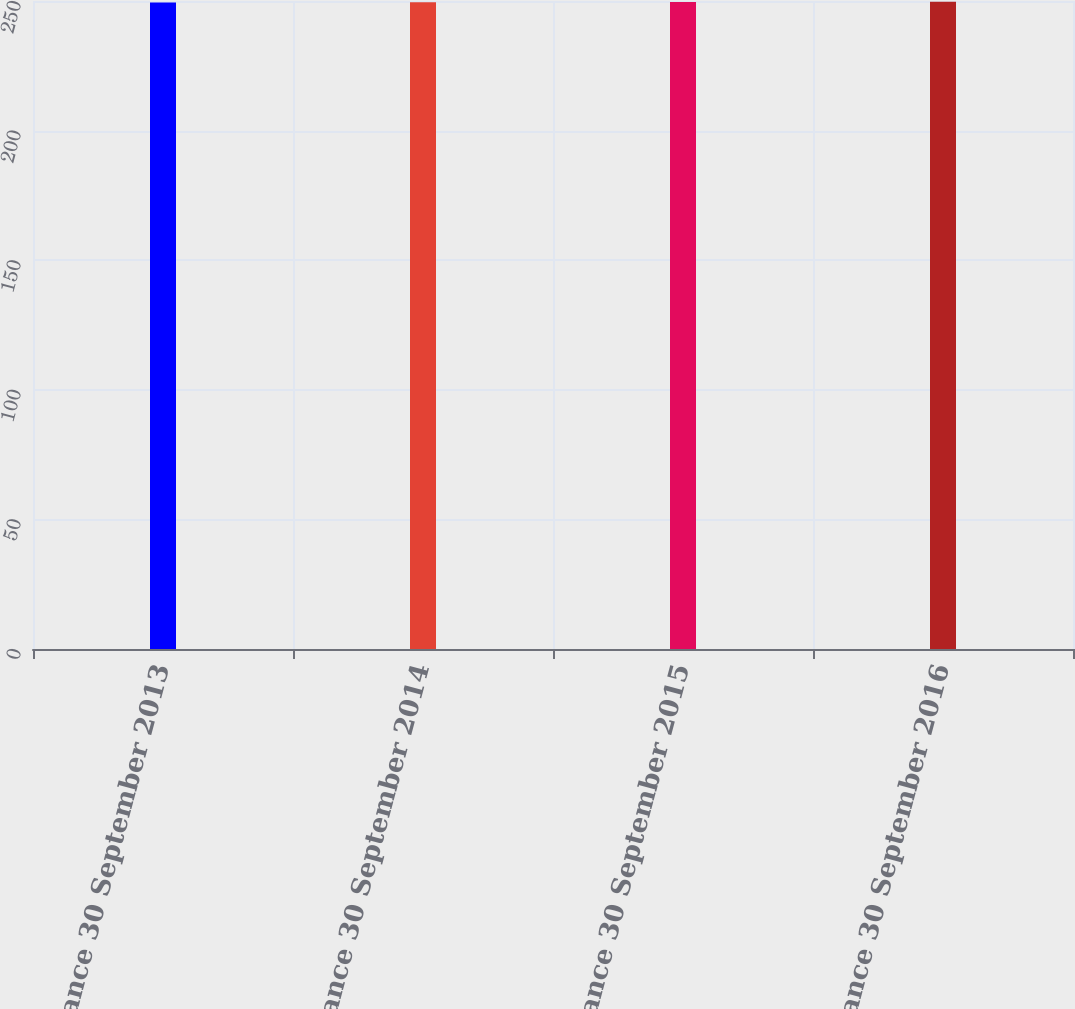<chart> <loc_0><loc_0><loc_500><loc_500><bar_chart><fcel>Balance 30 September 2013<fcel>Balance 30 September 2014<fcel>Balance 30 September 2015<fcel>Balance 30 September 2016<nl><fcel>249.4<fcel>249.5<fcel>249.6<fcel>249.7<nl></chart> 